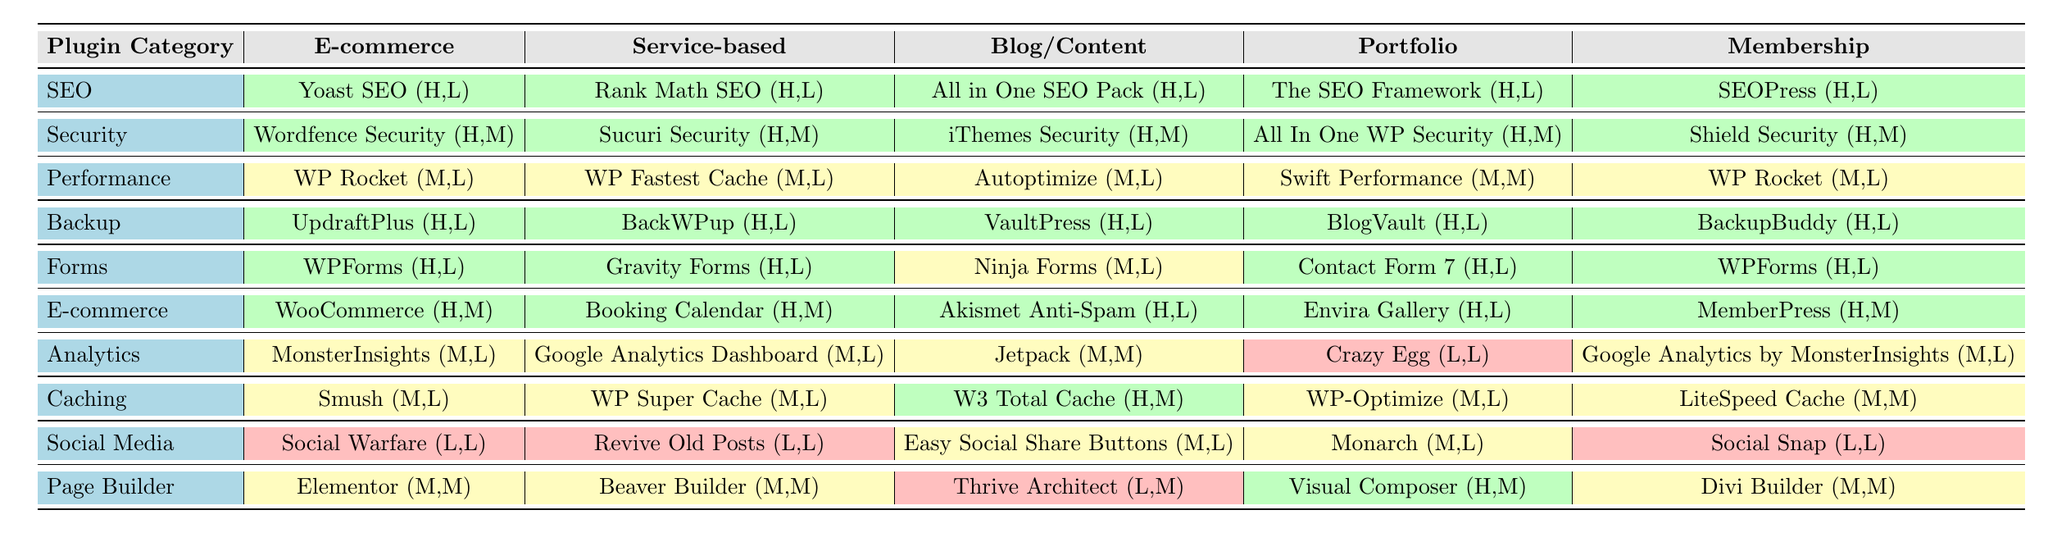What are the essential plugins for an E-commerce business? The table lists the essential plugins for an E-commerce business under the relevant categories. These are WooCommerce, Yoast SEO, Wordfence Security, WP Rocket, UpdraftPlus, WPForms, MonsterInsights, Smush, Social Warfare, and Elementor.
Answer: WooCommerce, Yoast SEO, Wordfence Security, WP Rocket, UpdraftPlus, WPForms, MonsterInsights, Smush, Social Warfare, Elementor Is it true that caching plugins are essential for all business types? The table shows that caching plugins are present in the E-commerce, Service-based, Blog/Content, and Membership categories but don't indicate them as essential across all business types. This implies that caching plugins are not listed for every type, thus it is false.
Answer: No Which plugin category has the most high-priority plugins for Blog/Content? Focusing on the Blog/Content column, the plugin categories with high-priority plugins listed are SEO, Security, and Backup, each having three high-priority plugins.
Answer: SEO, Security, and Backup Do all business types require a form plugin? By examining the table, Service-based and Blog/Content types have a form plugin listed, but E-commerce, Portfolio, and Membership have their own forms, indicating that forms are indeed required for all business types.
Answer: Yes Which business type has the highest number of security plugins listed and how many are there? The E-commerce, Service-based, and Membership types each have three security plugins listed. The Blog/Content and Portfolio types each have one. Thus, E-commerce, Service-based, and Membership tie for the most.
Answer: E-commerce, Service-based, and Membership; 3 What is the implementation complexity of using WooCommerce for an E-commerce business? Checking the table, WooCommerce is labeled with medium complexity under the E-commerce category. This means it is not too challenging to implement, but may take some effort.
Answer: Medium complexity If a service-based business only needs one backup plugin, which one is the best option based on the table? The table highlights two backup plugins for service-based businesses: BackWPup and it counts as high priority, so the best option would be either of them as they are both suitable choices and easy to implement.
Answer: BackWPup Is the Social Media plugin category prioritized equally across all business types? The table indicates that the Social Media category is marked as low priority for E-commerce, Service-based, and Membership businesses while medium for Blog/Content and Portfolio types, suggesting it is not prioritized equally.
Answer: No 